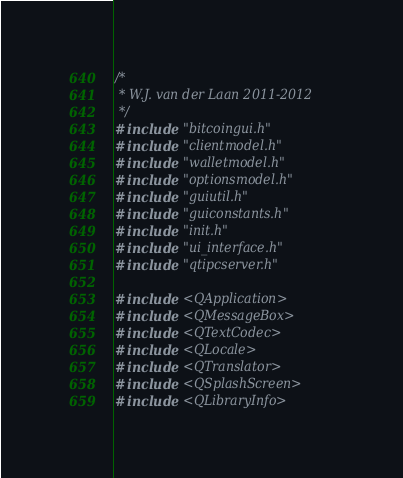<code> <loc_0><loc_0><loc_500><loc_500><_C++_>/*
 * W.J. van der Laan 2011-2012
 */
#include "bitcoingui.h"
#include "clientmodel.h"
#include "walletmodel.h"
#include "optionsmodel.h"
#include "guiutil.h"
#include "guiconstants.h"
#include "init.h"
#include "ui_interface.h"
#include "qtipcserver.h"

#include <QApplication>
#include <QMessageBox>
#include <QTextCodec>
#include <QLocale>
#include <QTranslator>
#include <QSplashScreen>
#include <QLibraryInfo>
</code> 